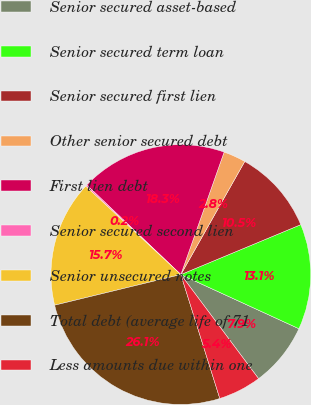Convert chart to OTSL. <chart><loc_0><loc_0><loc_500><loc_500><pie_chart><fcel>Senior secured asset-based<fcel>Senior secured term loan<fcel>Senior secured first lien<fcel>Other senior secured debt<fcel>First lien debt<fcel>Senior secured second lien<fcel>Senior unsecured notes<fcel>Total debt (average life of 71<fcel>Less amounts due within one<nl><fcel>7.95%<fcel>13.12%<fcel>10.54%<fcel>2.78%<fcel>18.3%<fcel>0.19%<fcel>15.71%<fcel>26.06%<fcel>5.36%<nl></chart> 